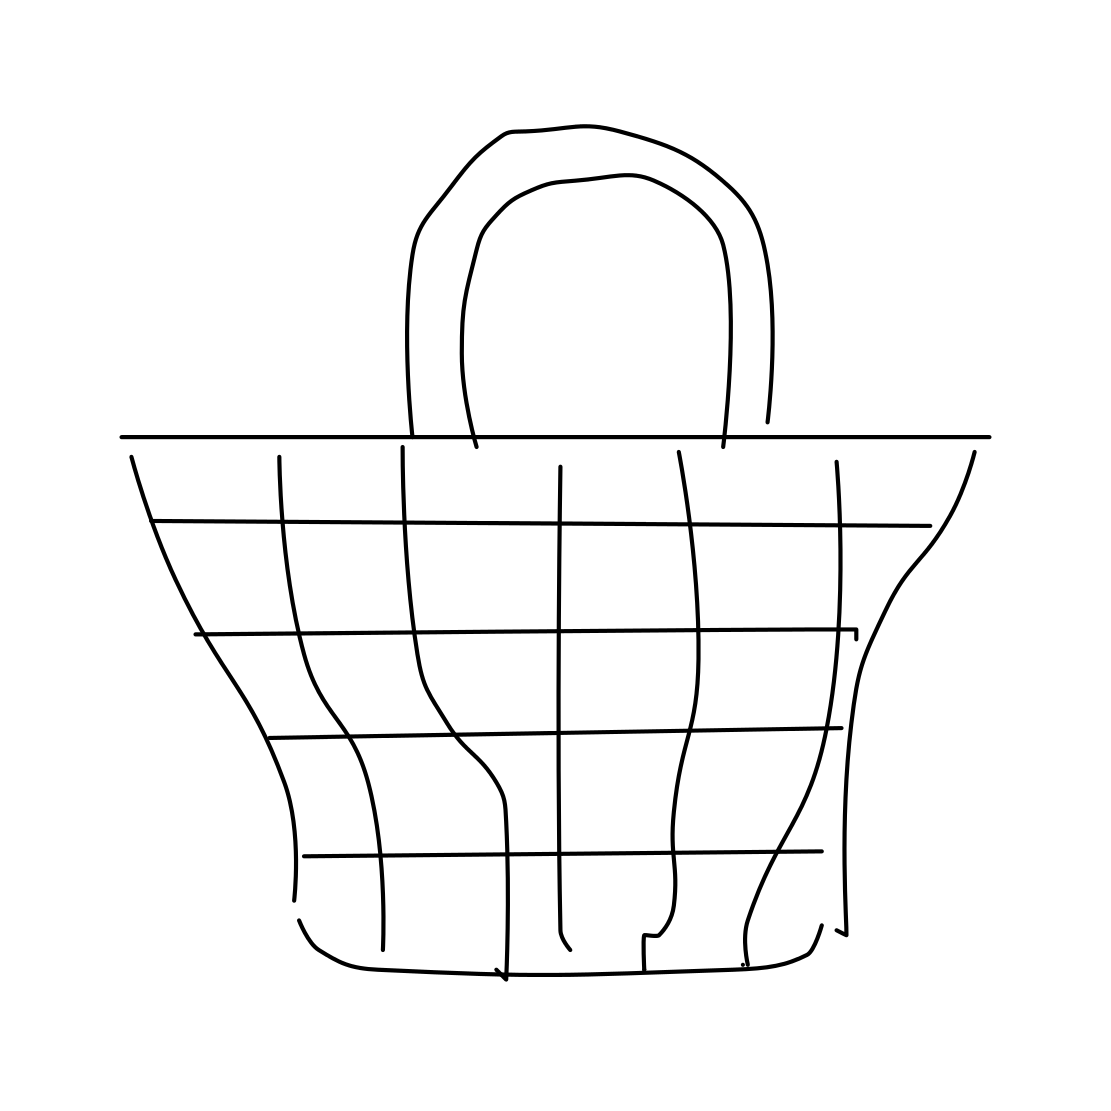Could this basket be used for shopping? Yes, the design of the basket, with its wide opening and handles, suggests it could be used for shopping. However, since it's a simple, flat drawing, this is a hypothetical use. In practical scenarios, such a shape would be suitable for carrying items, especially if it were sturdy. 